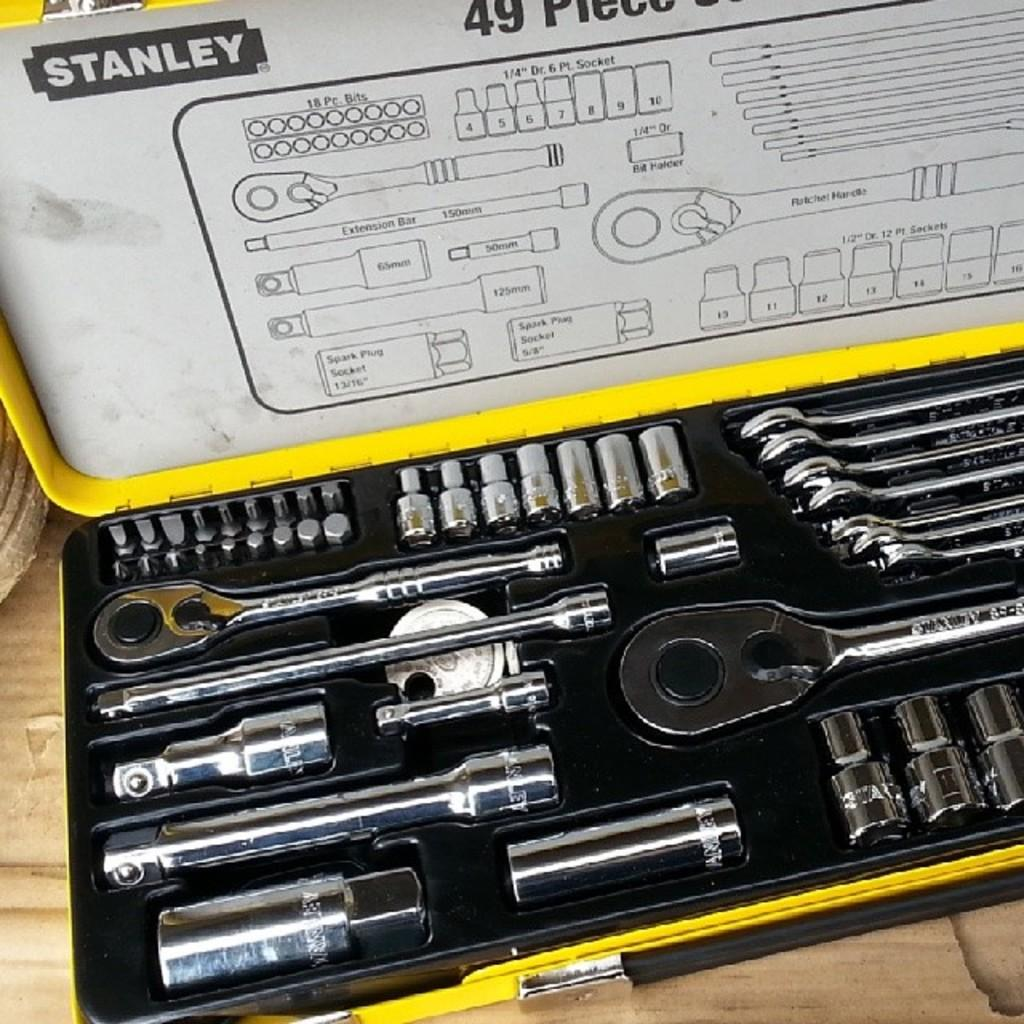What objects are present in the image? There are tools in the image. Where are the tools located? The tools are in a box. How does the division of labor affect the tools in the image? There is no indication of division of labor in the image, as it only shows tools in a box. 